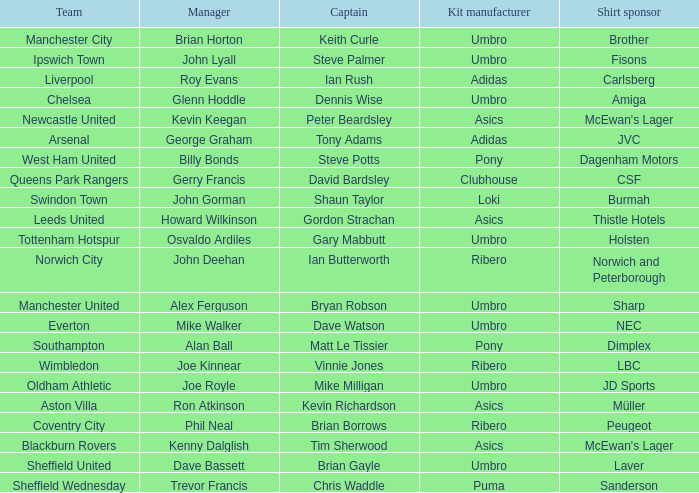Which team has george graham as the manager? Arsenal. 